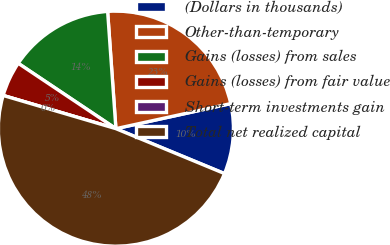Convert chart to OTSL. <chart><loc_0><loc_0><loc_500><loc_500><pie_chart><fcel>(Dollars in thousands)<fcel>Other-than-temporary<fcel>Gains (losses) from sales<fcel>Gains (losses) from fair value<fcel>Short-term investments gain<fcel>Total net realized capital<nl><fcel>9.66%<fcel>22.7%<fcel>14.49%<fcel>4.83%<fcel>0.0%<fcel>48.31%<nl></chart> 